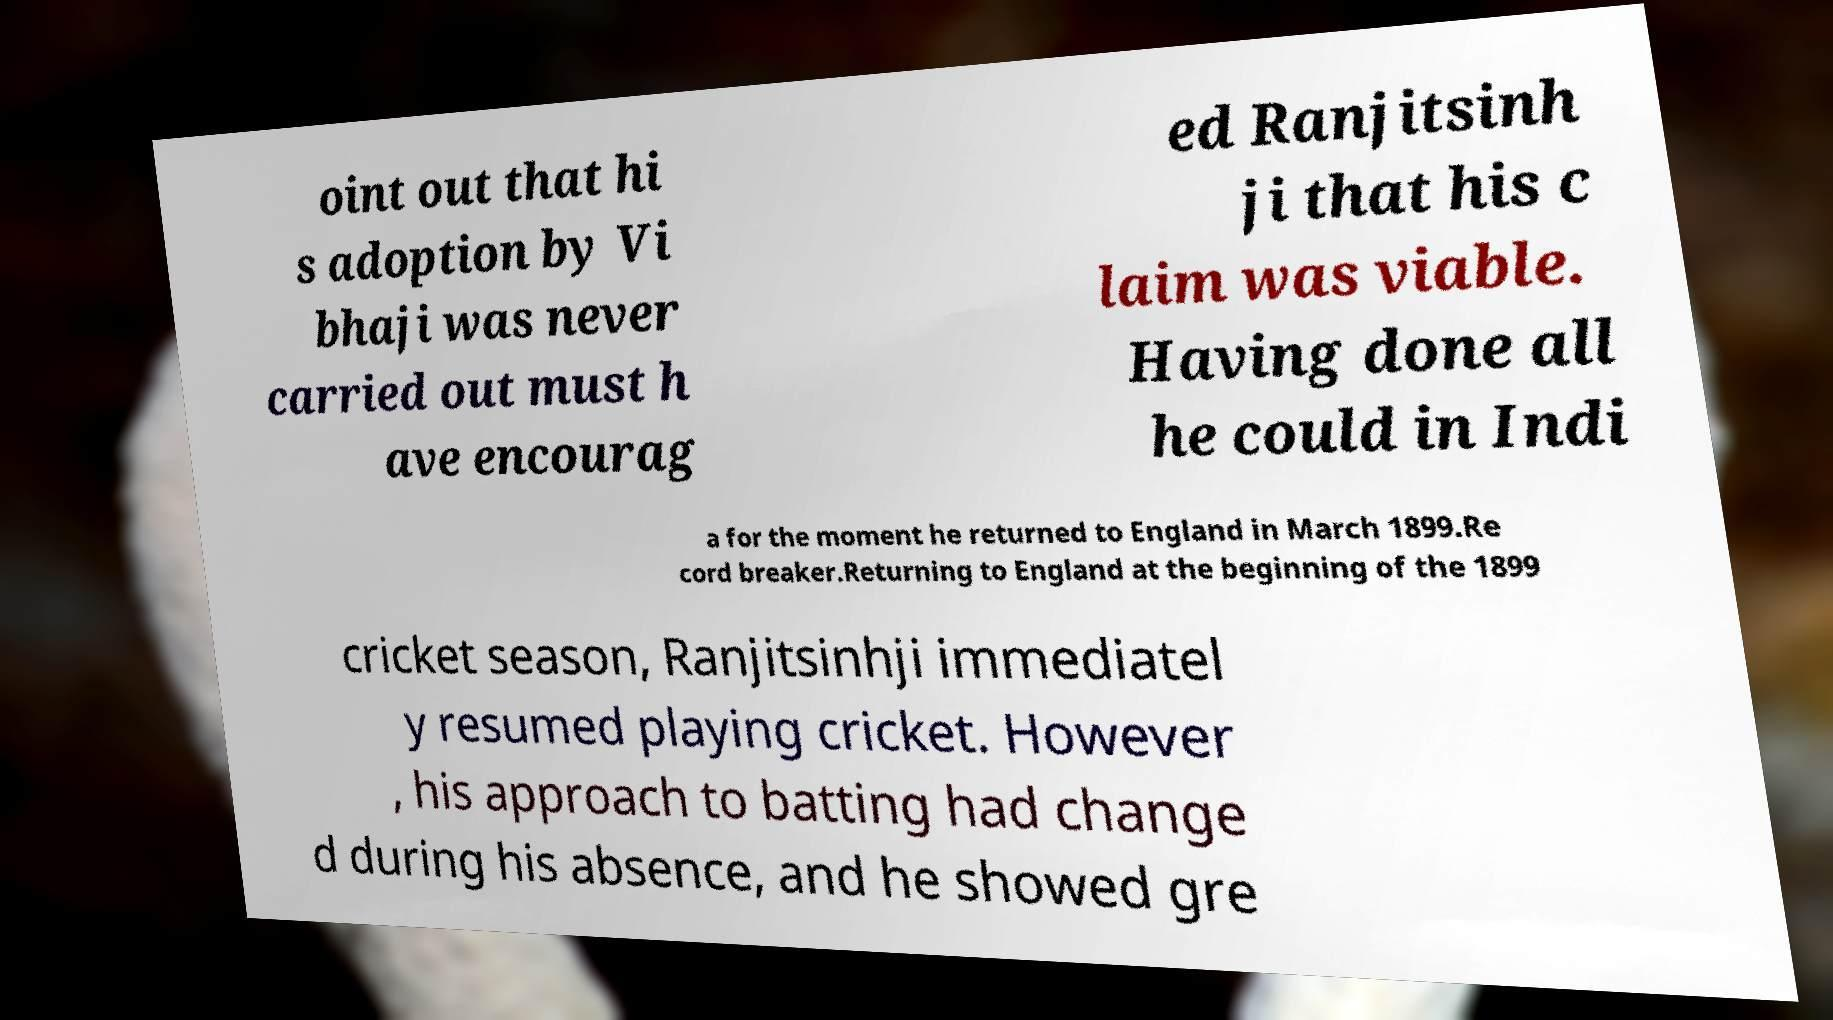Please read and relay the text visible in this image. What does it say? oint out that hi s adoption by Vi bhaji was never carried out must h ave encourag ed Ranjitsinh ji that his c laim was viable. Having done all he could in Indi a for the moment he returned to England in March 1899.Re cord breaker.Returning to England at the beginning of the 1899 cricket season, Ranjitsinhji immediatel y resumed playing cricket. However , his approach to batting had change d during his absence, and he showed gre 